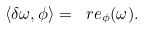<formula> <loc_0><loc_0><loc_500><loc_500>\langle \delta \omega , \phi \rangle = \ r e _ { \phi } ( \omega ) .</formula> 